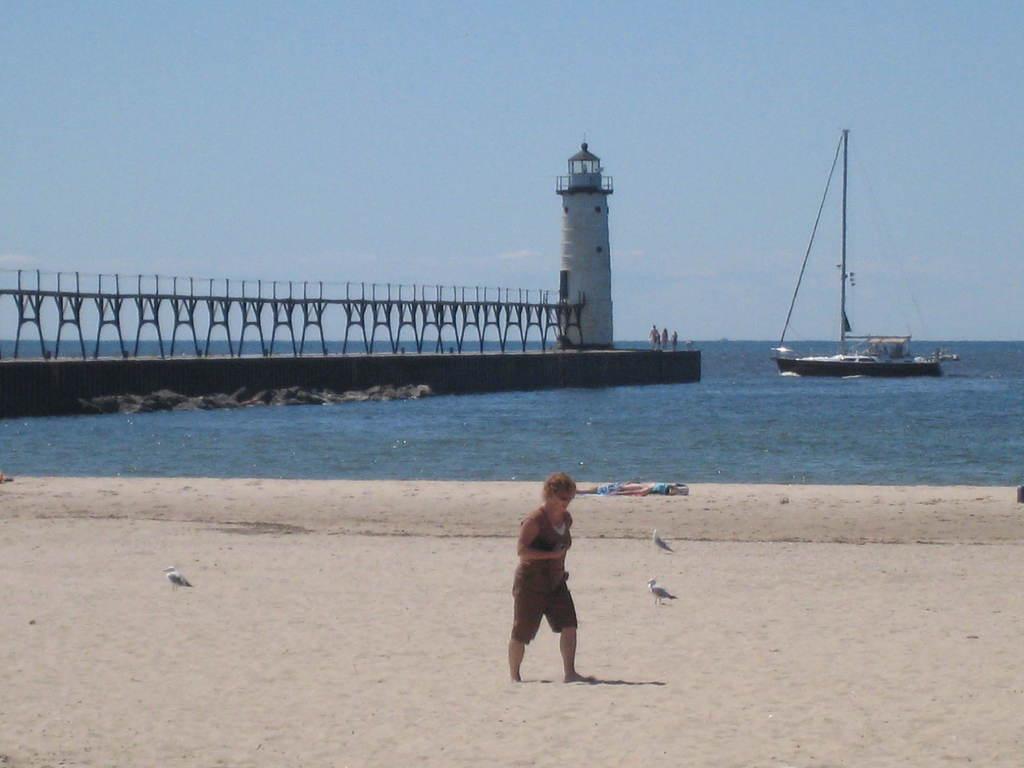Describe this image in one or two sentences. In the foreground of the picture there are birds, a person walking and sand. In the center of the picture there is a water body, in the water there is a boat. In the center of the picture towards left there is dock, at the end of the dock it is lighthouse. Sky is sunny. 